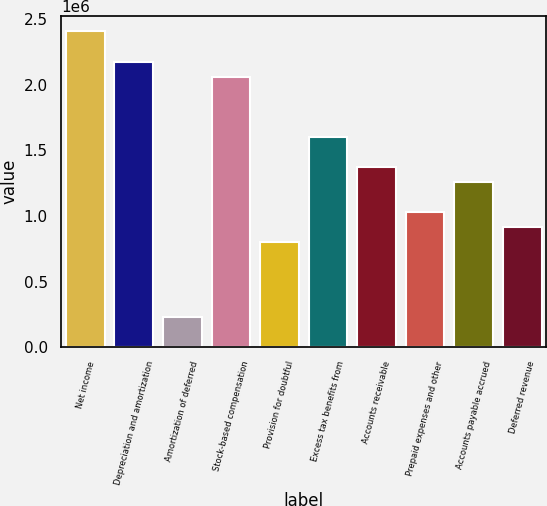Convert chart to OTSL. <chart><loc_0><loc_0><loc_500><loc_500><bar_chart><fcel>Net income<fcel>Depreciation and amortization<fcel>Amortization of deferred<fcel>Stock-based compensation<fcel>Provision for doubtful<fcel>Excess tax benefits from<fcel>Accounts receivable<fcel>Prepaid expenses and other<fcel>Accounts payable accrued<fcel>Deferred revenue<nl><fcel>2.40744e+06<fcel>2.17818e+06<fcel>229439<fcel>2.06355e+06<fcel>802598<fcel>1.60502e+06<fcel>1.37576e+06<fcel>1.03186e+06<fcel>1.26112e+06<fcel>917230<nl></chart> 